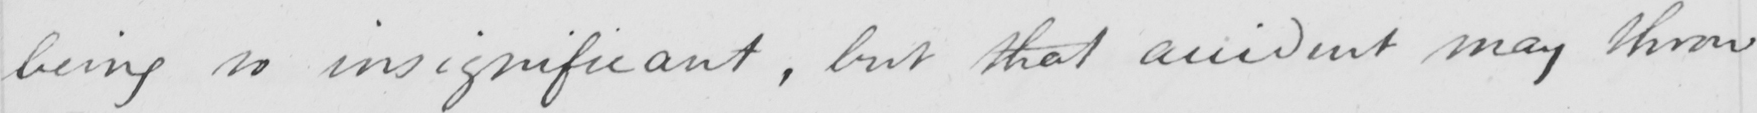What does this handwritten line say? being is insignificant , but that accident may throw 